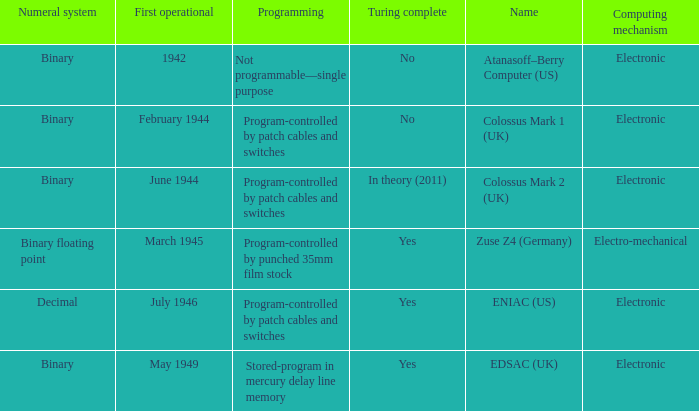What's the turing complete with numeral system being decimal Yes. Parse the full table. {'header': ['Numeral system', 'First operational', 'Programming', 'Turing complete', 'Name', 'Computing mechanism'], 'rows': [['Binary', '1942', 'Not programmable—single purpose', 'No', 'Atanasoff–Berry Computer (US)', 'Electronic'], ['Binary', 'February 1944', 'Program-controlled by patch cables and switches', 'No', 'Colossus Mark 1 (UK)', 'Electronic'], ['Binary', 'June 1944', 'Program-controlled by patch cables and switches', 'In theory (2011)', 'Colossus Mark 2 (UK)', 'Electronic'], ['Binary floating point', 'March 1945', 'Program-controlled by punched 35mm film stock', 'Yes', 'Zuse Z4 (Germany)', 'Electro-mechanical'], ['Decimal', 'July 1946', 'Program-controlled by patch cables and switches', 'Yes', 'ENIAC (US)', 'Electronic'], ['Binary', 'May 1949', 'Stored-program in mercury delay line memory', 'Yes', 'EDSAC (UK)', 'Electronic']]} 